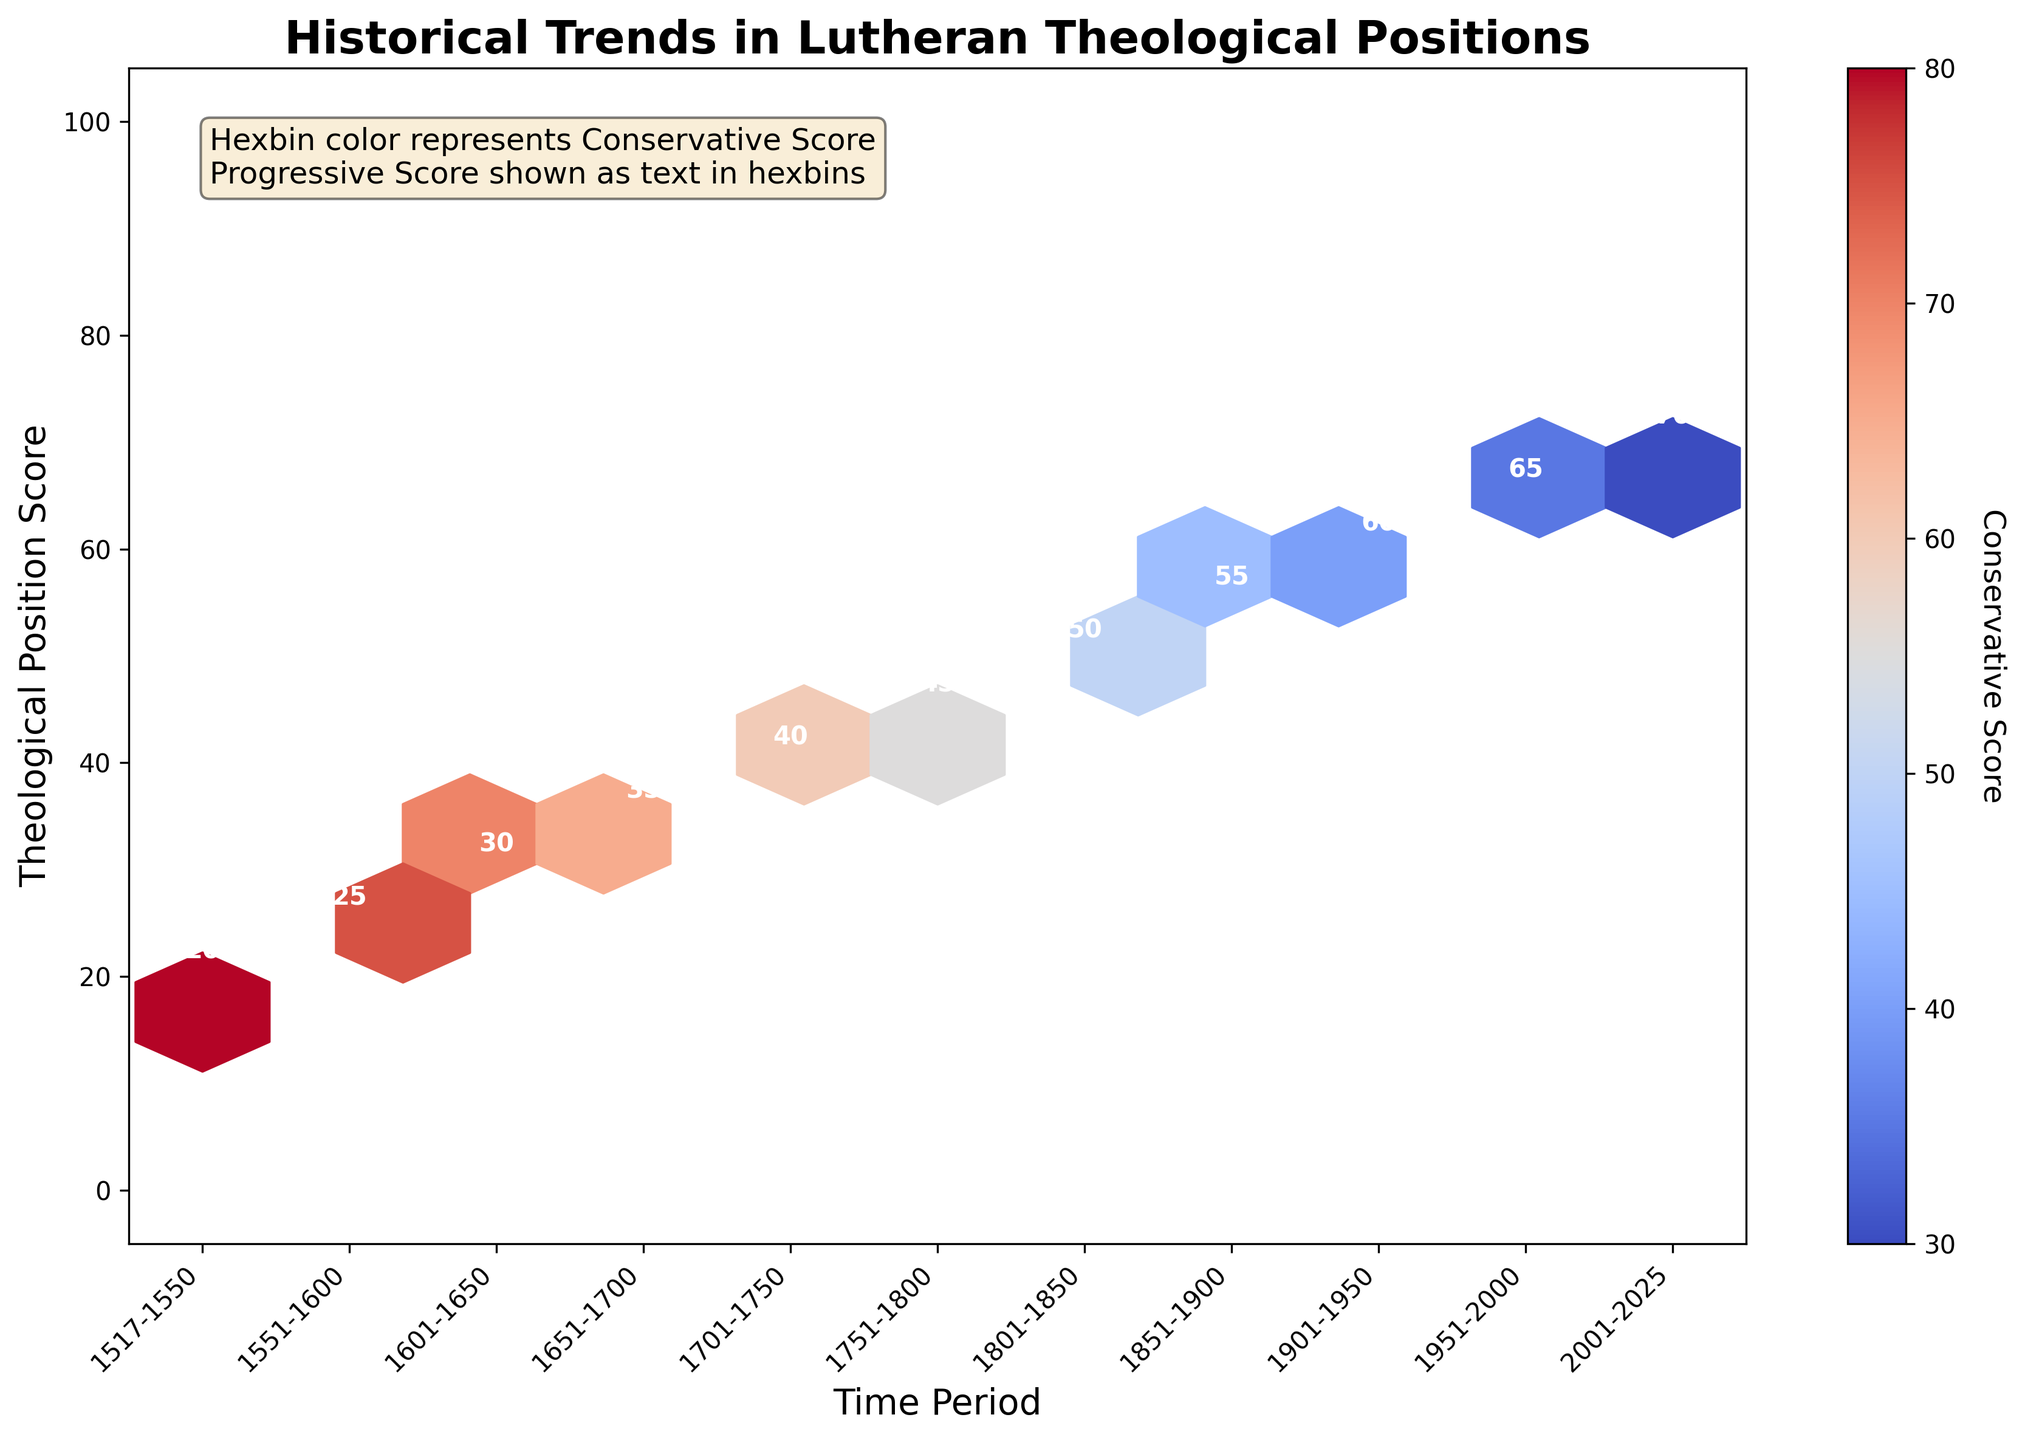What is the title of the plot? The title is written at the top of the figure in large, bold font, indicating the main focus of the visualized data.
Answer: Historical Trends in Lutheran Theological Positions How does the progressive score trend from the time period 1517-1550 to 2001-2025? Follow the annotations inside each hexbin from left to right. Begin with the 1517-1550 period and end with the 2001-2025 period, observing the changes in the numbers.
Answer: It increases What period has the highest conservative score and how is it represented in the plot? Identify the hexbin with the darkest shade of color since higher conservative scores correspond to darker shades on the color scale. Then check the annotation for corresponding period.
Answer: 1517-1550 with a score of 80 How many time periods are represented in the hexbin plot? Count the number of distinct hexbins along the x-axis, each with unique annotations for the Progressive Score. These represent different time periods.
Answer: 11 Which time period marks the shift where progressive views score higher than 50? Find the hexbin with a progressive score annotation higher than 50 and note the corresponding time period.
Answer: 1851-1900 Compare the progressive score differences between the time periods 1551-1600 and 1701-1750. Subtract the progressive score of the earlier period (1551-1600) from the progressive score of the later period (1701-1750).
Answer: 40 - 25 = 15 From which time period onwards does the conservative score display a continuous decreasing trend? Observe the hexbin colors (conservative score changes) and identify the time period where decreasing color intensity begins and continues.
Answer: 1801-1850 What does the color gradient in the plot represent, and how is this information visually conveyed? The color gradient represents the conservative score; darker shades indicate higher scores, as shown in the color bar legend on the right side of the plot.
Answer: Conservative Score How is the information about progressive scores visually emphasized in the plot? The progressive scores are directly annotated as text inside each hexbin, and annotations are white and bold for better readability against the color gradients representing conservative scores.
Answer: Annotated as text in hexbins 